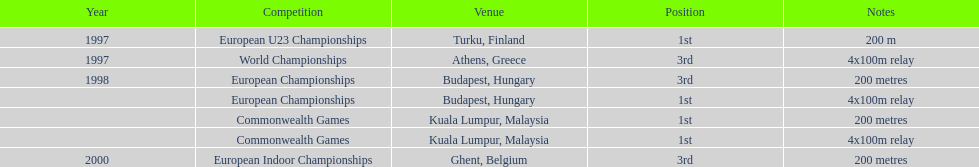Name the events that include the same relay race as the athens, greece world championships. European Championships, Commonwealth Games. 